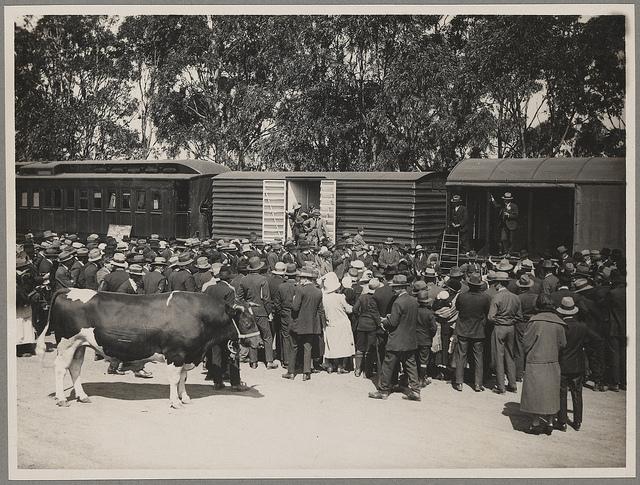Was this photo taken last year?
Answer briefly. No. What kind of animals are in the picture?
Quick response, please. Cow. Is this a cattle auction?
Keep it brief. No. What color scheme was the photo taken in?
Quick response, please. Black and white. What is the lady doing to the cow?
Short answer required. Nothing. How many people are pictured?
Answer briefly. 50. 